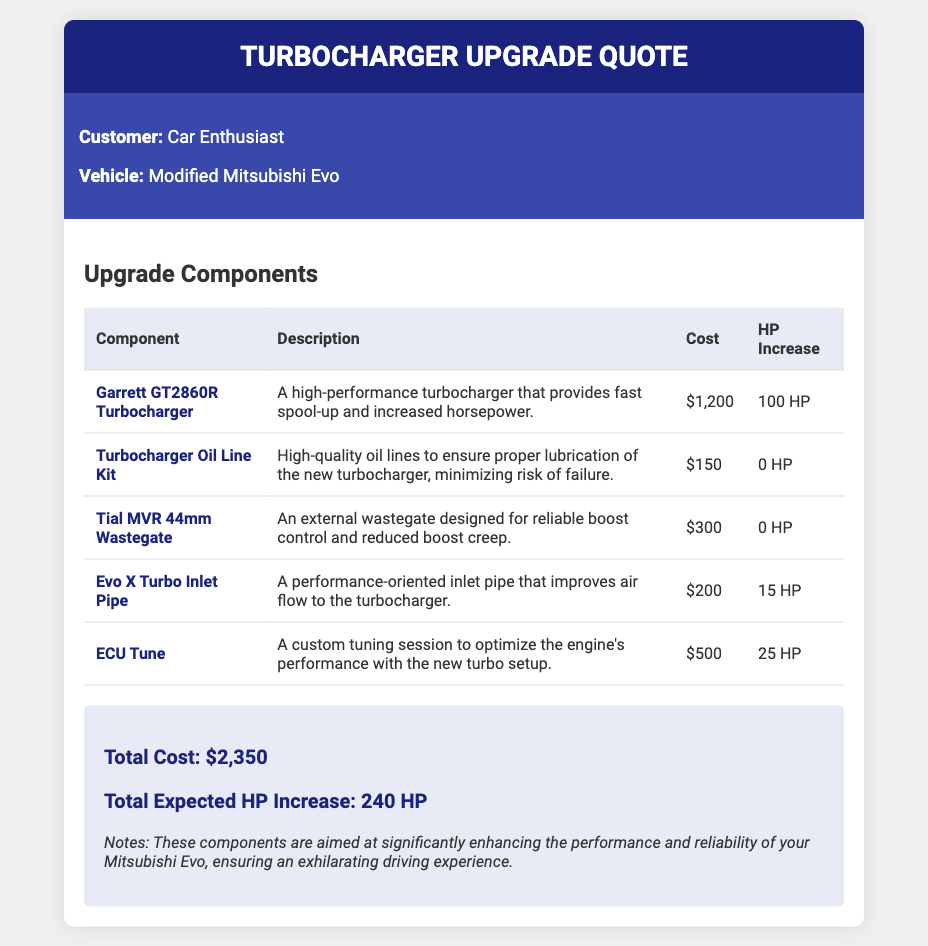What is the total cost of the upgrade? The total cost is provided in the summary section of the document.
Answer: $2,350 What is the expected horsepower increase from the Garrett GT2860R Turbocharger? The horsepower increase from this specific component is listed in the table.
Answer: 100 HP What component is included for boost control? The document specifies the component designed for boost control in the table.
Answer: Tial MVR 44mm Wastegate What is the cost of the ECU Tune? The cost for this tuning session is detailed in the upgrade components table.
Answer: $500 How much horsepower will the Evo X Turbo Inlet Pipe add? The horsepower increase from the Evo X Turbo Inlet Pipe is indicated in the table.
Answer: 15 HP What is the total expected horsepower increase from all components? The total expected horsepower increase is mentioned in the summary section of the document.
Answer: 240 HP Who is the customer listed in the document? The customer's name is specified in the customer information section.
Answer: Car Enthusiast What does the Turbocharger Oil Line Kit ensure? The document describes the purpose of this kit in the description column of the table.
Answer: Proper lubrication What kind of experience is aimed for with these upgrades? The notes section of the document mentions the intended outcome of the upgrades.
Answer: Exhilarating driving experience 